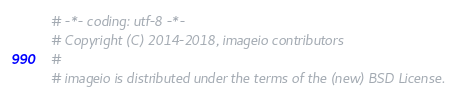<code> <loc_0><loc_0><loc_500><loc_500><_Python_># -*- coding: utf-8 -*-
# Copyright (C) 2014-2018, imageio contributors
#
# imageio is distributed under the terms of the (new) BSD License.</code> 